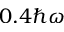Convert formula to latex. <formula><loc_0><loc_0><loc_500><loc_500>0 . 4 \hbar { \omega }</formula> 